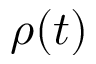Convert formula to latex. <formula><loc_0><loc_0><loc_500><loc_500>\rho ( t )</formula> 